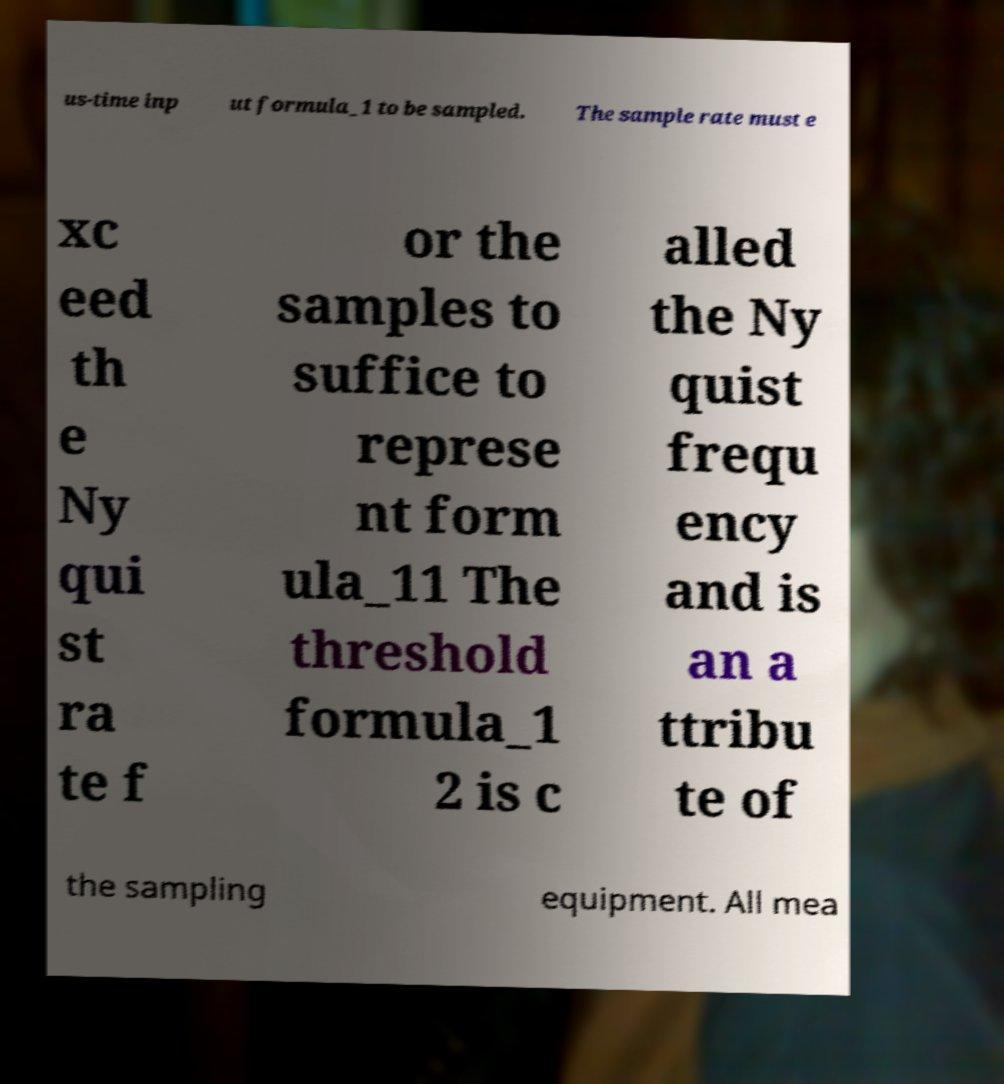What messages or text are displayed in this image? I need them in a readable, typed format. us-time inp ut formula_1 to be sampled. The sample rate must e xc eed th e Ny qui st ra te f or the samples to suffice to represe nt form ula_11 The threshold formula_1 2 is c alled the Ny quist frequ ency and is an a ttribu te of the sampling equipment. All mea 